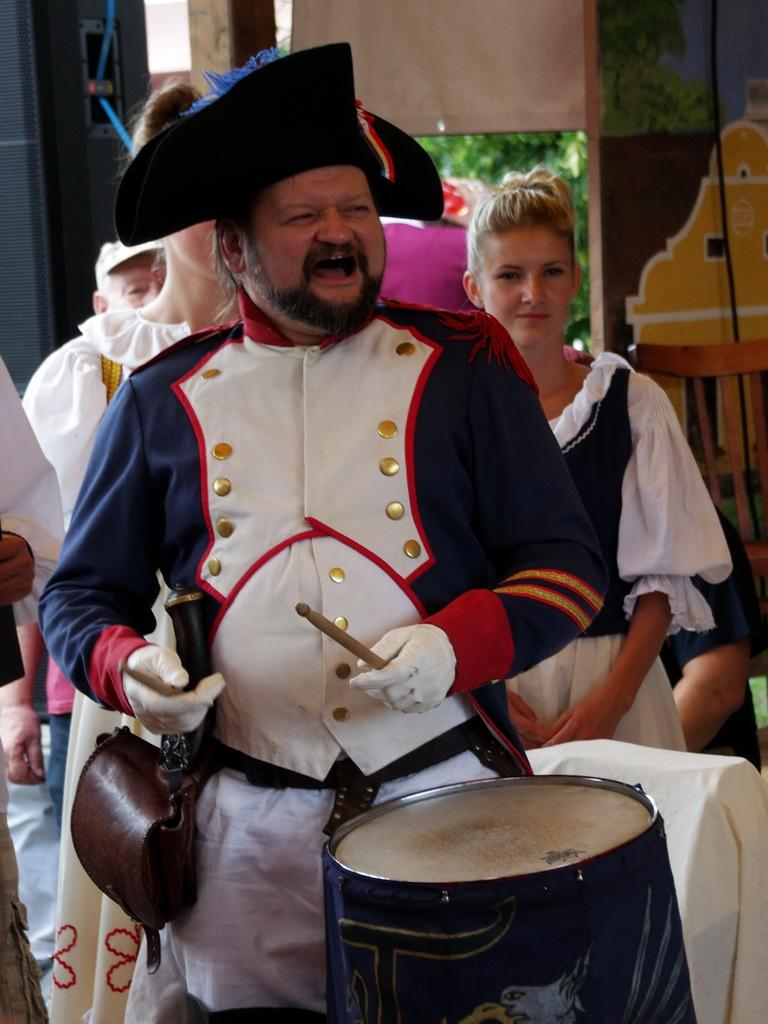What is the man in the image doing? The man is playing a drum. What is the man wearing in the image? The man is wearing a blue and green dress and a hat. Are there any other people in the image? Yes, there are women behind the man. What can be seen in the background of the image? There is a curtain in the background of the image. What type of leather is used to make the man's hat in the image? There is no information about the material used to make the hat in the image. How much popcorn is being consumed by the man in the image? There is no popcorn present in the image. 